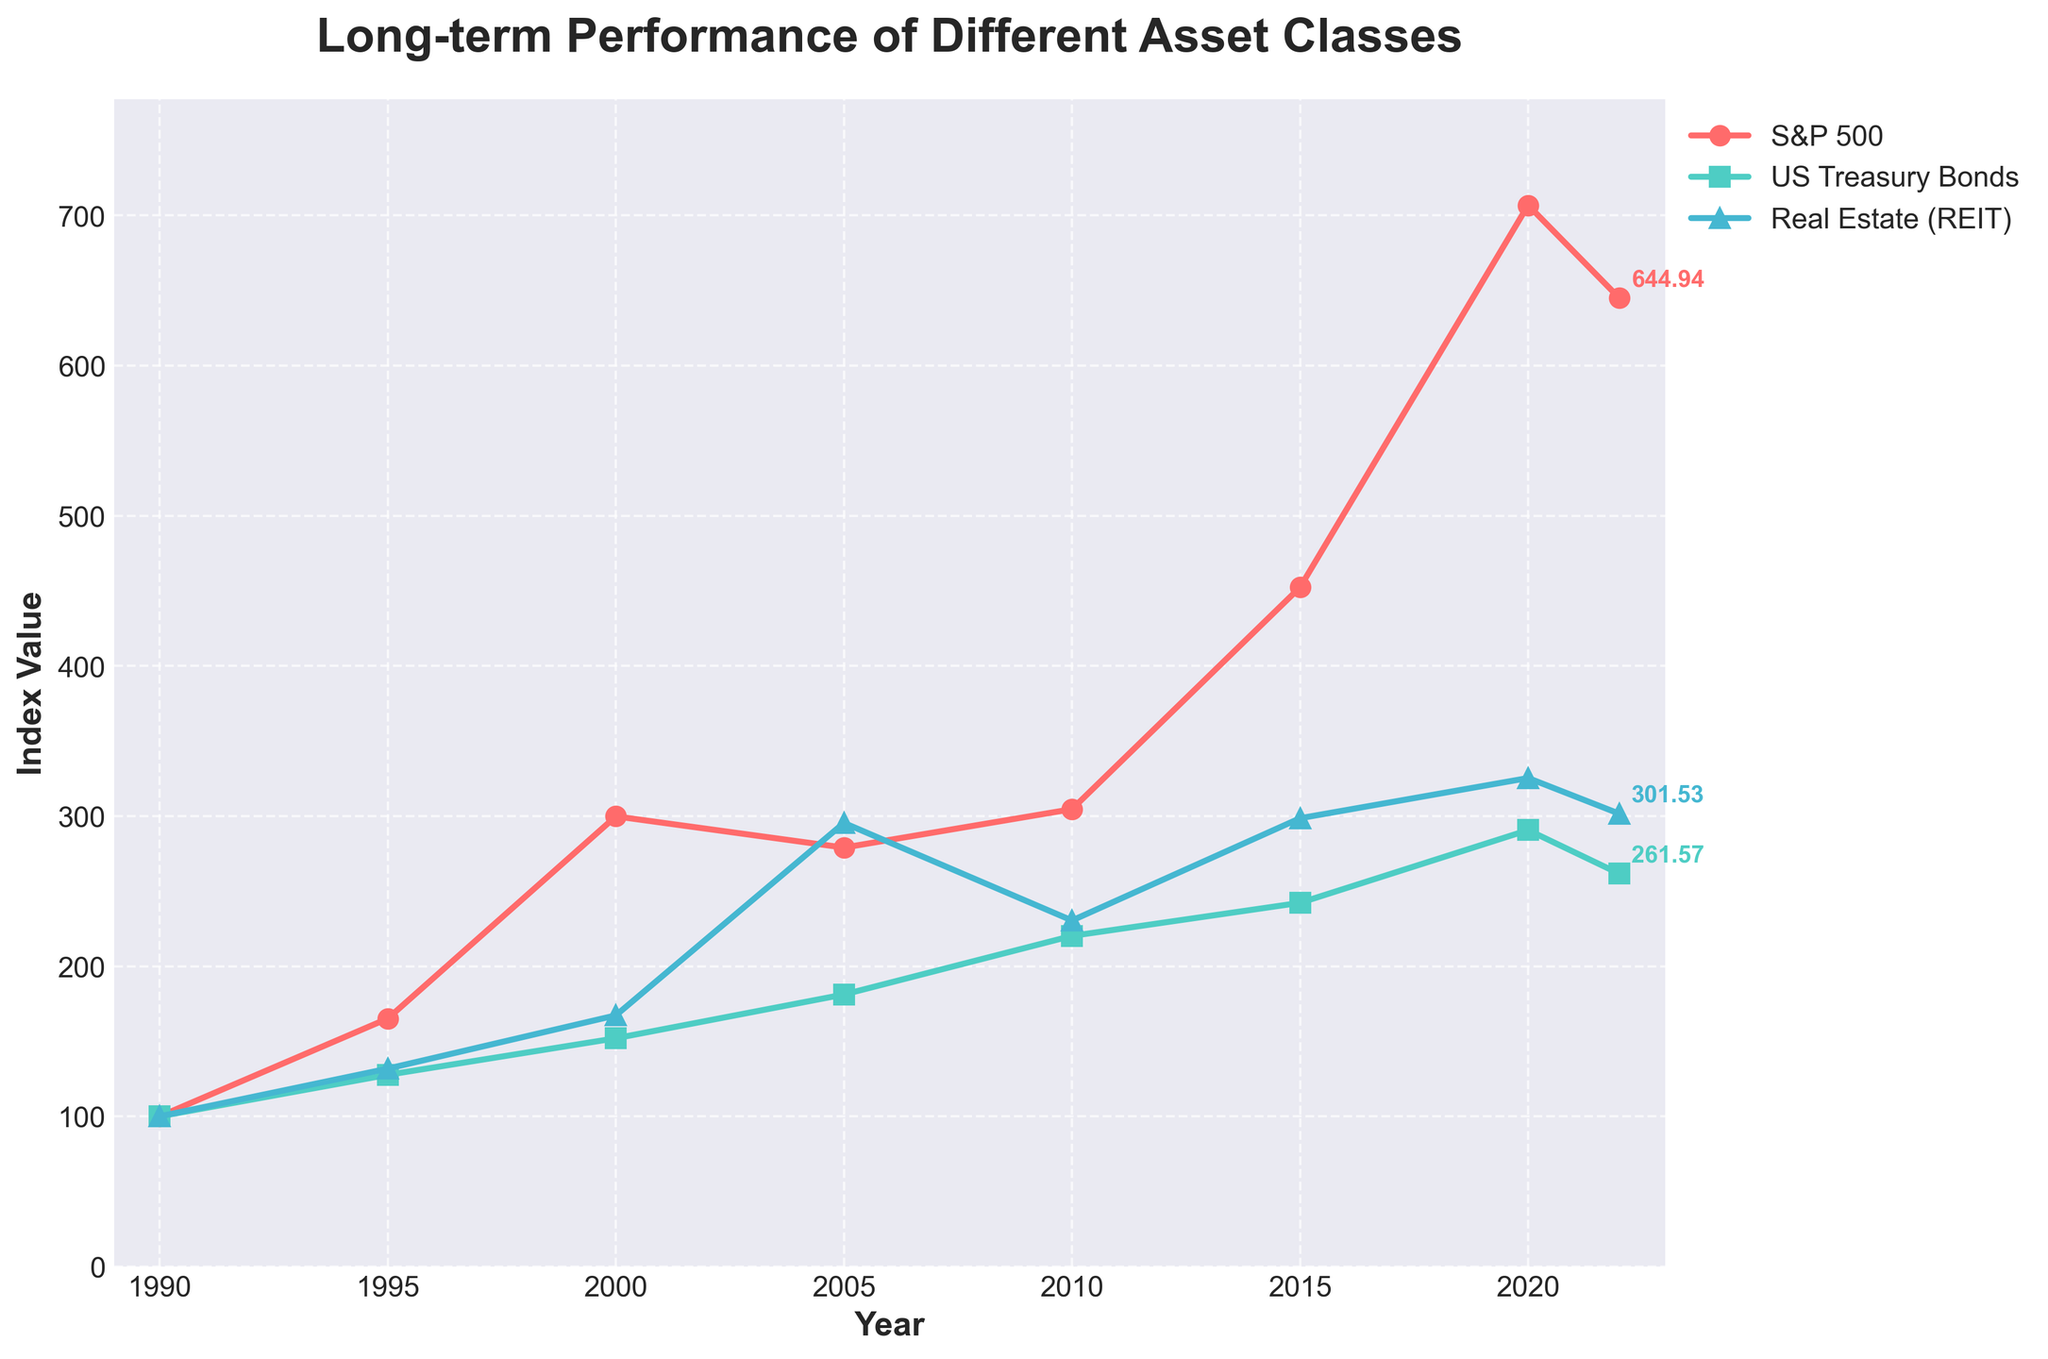Which asset class had the highest index value in 2020? In 2020, the S&P 500 had an index value of 706.84, US Treasury Bonds had 290.63, and Real Estate had 325.31. The S&P 500 has the highest value among the three.
Answer: S&P 500 What was the difference in the index value of US Treasury Bonds between 2005 and 2022? In 2005, the index value of US Treasury Bonds was 181.13, and in 2022 it was 261.57. The difference is 261.57 - 181.13 = 80.44.
Answer: 80.44 Which asset class showed the highest growth between 1990 and 2020? The index values in 1990 were all 100. In 2020, the values were 706.84 for S&P 500, 290.63 for US Treasury Bonds, and 325.31 for Real Estate. The S&P 500 grew the most, from 100 to 706.84, which is an increase of 606.84.
Answer: S&P 500 By how much did the index value of Real Estate (REIT) decrease from 2020 to 2022? In 2020, the index value for Real Estate was 325.31, and in 2022 it was 301.53. The decrease is 325.31 - 301.53 = 23.78.
Answer: 23.78 Between 1995 and 2015, which asset class showed the least growth in index value? In 1995, the index values were: S&P 500: 165.13, US Treasury Bonds: 127.63, Real Estate: 131.76. In 2015, the values were: S&P 500: 452.34, US Treasury Bonds: 242.19, Real Estate: 298.54. The growths: S&P 500: 452.34 - 165.13 = 287.21, US Treasury Bonds: 242.19 - 127.63 = 114.56, Real Estate: 298.54 - 131.76 = 166.78. US Treasury Bonds had the least growth.
Answer: US Treasury Bonds Which year showed the smallest increase in the index value of the S&P 500 compared to the previous recorded year in the dataset? Comparing year-to-year increases: 1995-1990: 165.13 - 100 = 65.13, 2000-1995: 299.77 - 165.13 = 134.64, 2005-2000: 278.97 - 299.77 = -20.80 (decrease), 2010-2005: 304.57 - 278.97 = 25.6, 2015-2010: 452.34 - 304.57 = 147.77, 2020-2015: 706.84 - 452.34 = 254.5. The smallest increase, excluding the decrease, is between 2005 and 2010 (25.6).
Answer: 2010 What is the average index value of Real Estate (REIT) across all years in the dataset? Summing all values of Real Estate: 100 + 131.76 + 167.24 + 295.41 + 230.42 + 298.54 + 325.31 + 301.53 = 1850.21. There are 8 recorded years. The average is 1850.21 / 8 = 231.28.
Answer: 231.28 